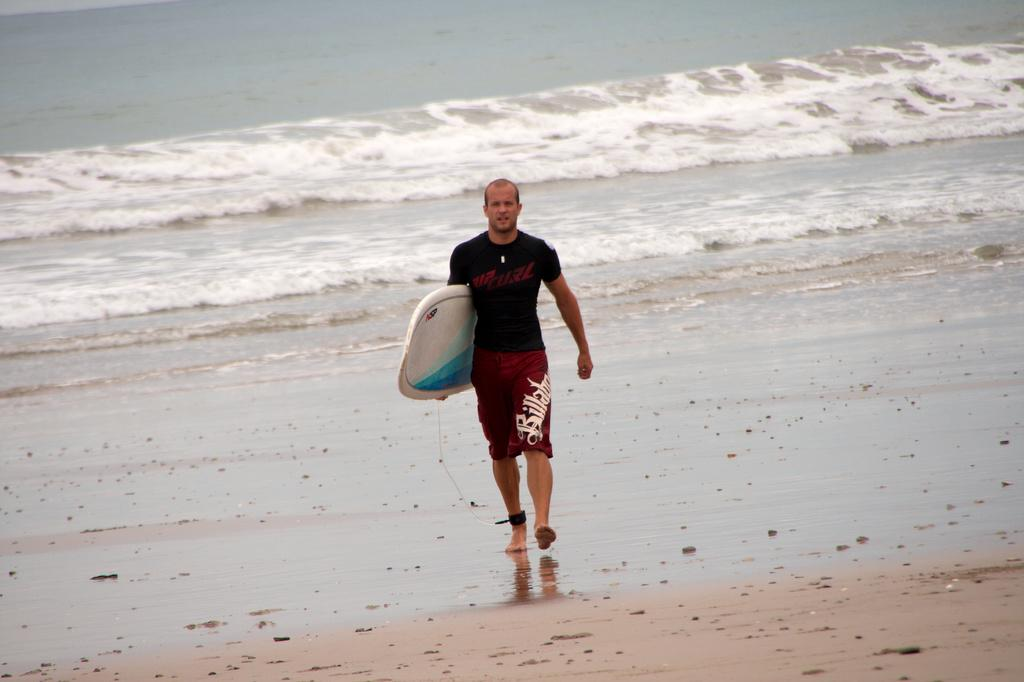Who or what is present in the image? There is a person in the image. What is the person holding? The person is holding a surfboard. What is the person doing in the image? The person is walking. What can be seen in the background of the image? There is water visible in the background of the image. What type of harmony is being played at the event in the image? There is no event or harmony present in the image; it features a person walking with a surfboard. Can you tell me how many skateboards are visible in the image? There are no skateboards visible in the image; it features a person walking with a surfboard. 